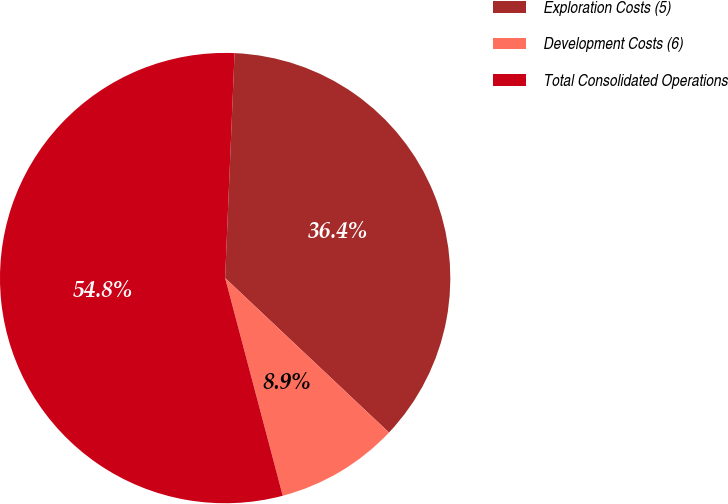<chart> <loc_0><loc_0><loc_500><loc_500><pie_chart><fcel>Exploration Costs (5)<fcel>Development Costs (6)<fcel>Total Consolidated Operations<nl><fcel>36.36%<fcel>8.85%<fcel>54.78%<nl></chart> 